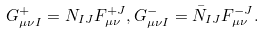Convert formula to latex. <formula><loc_0><loc_0><loc_500><loc_500>G _ { \mu \nu I } ^ { + } = N _ { I J } F _ { \mu \nu } ^ { + J } , G _ { \mu \nu I } ^ { - } = \bar { N } _ { I J } F _ { \mu \nu } ^ { - J } .</formula> 